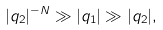<formula> <loc_0><loc_0><loc_500><loc_500>| q _ { 2 } | ^ { - N } \gg | q _ { 1 } | \gg | q _ { 2 } | ,</formula> 